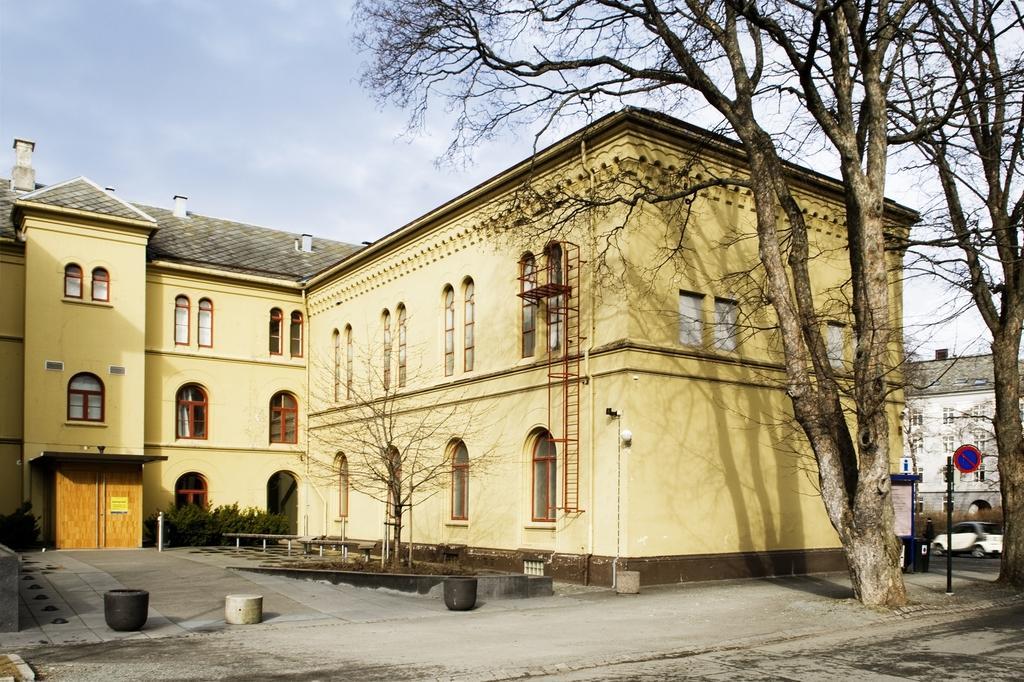Can you describe this image briefly? This picture is clicked outside. In the foreground we can see the trees, metal rods and some other objects. In the background we can see the sky and the buildings, plants, metal rods, a vehicle and some other objects. 